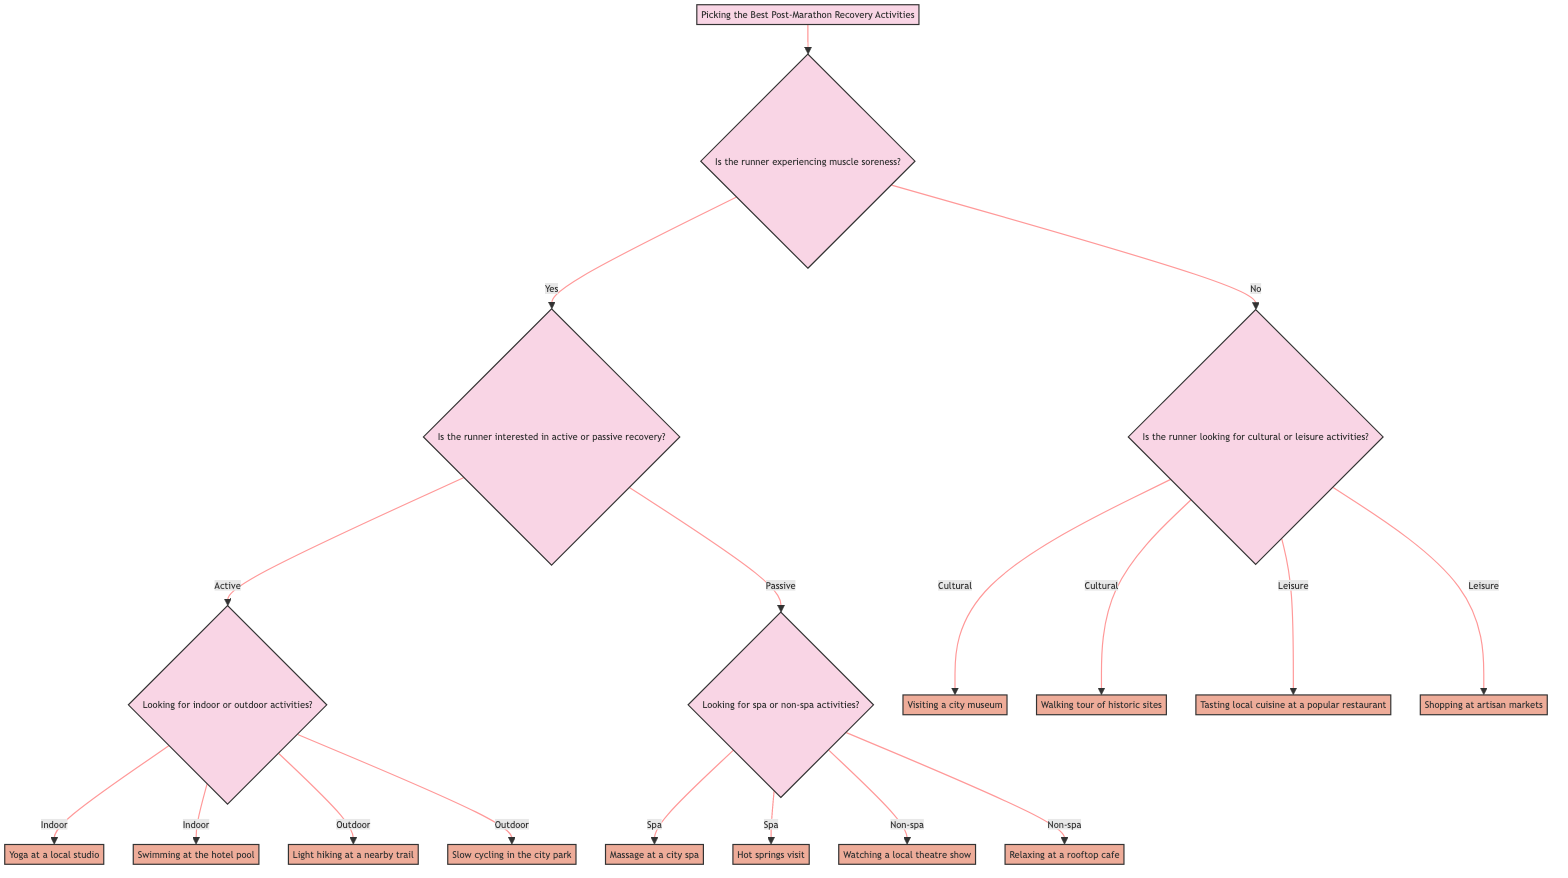What is the first question in the decision tree? The first question in the decision tree is located at the top of the tree, which asks "Is the runner experiencing muscle soreness?"
Answer: Is the runner experiencing muscle soreness? How many main branches come from the first question? The first question has two branches: one for "Yes" and one for "No." This indicates the two possible scenarios based on the response.
Answer: 2 If the runner has muscle soreness and prefers active recovery, what activities are suggested? Following the path of "Yes" to muscle soreness and then to active recovery, the diagram shows two activities: indoor and outdoor options. The indoor activities are "Yoga at a local studio" and "Swimming at the hotel pool," while the outdoor activities are "Light hiking at a nearby trail" and "Slow cycling in the city park."
Answer: Yoga at a local studio, Swimming at the hotel pool, Light hiking at a nearby trail, Slow cycling in the city park What options are available if the runner chooses passive recovery and prefers spa activities? From the decision tree, if the runner selects passive recovery and specifically spa activities, the suggested options are "Massage at a city spa" and "Hot springs visit."
Answer: Massage at a city spa, Hot springs visit What does the runner choose if they have no muscle soreness and are looking for cultural activities? For runners who answer "No" to muscle soreness and choose the cultural activities branch, the activities available are "Visiting a city museum" and "Walking tour of historic sites."
Answer: Visiting a city museum, Walking tour of historic sites What is the final category of activities if the runner prefers leisure activities after indicating no muscle soreness? If the runner indicates no muscle soreness and selects leisure activities, the options are "Tasting local cuisine at a popular restaurant" and "Shopping at artisan markets." These activities can be undertaken for relaxation and enjoyment in the city.
Answer: Tasting local cuisine at a popular restaurant, Shopping at artisan markets 